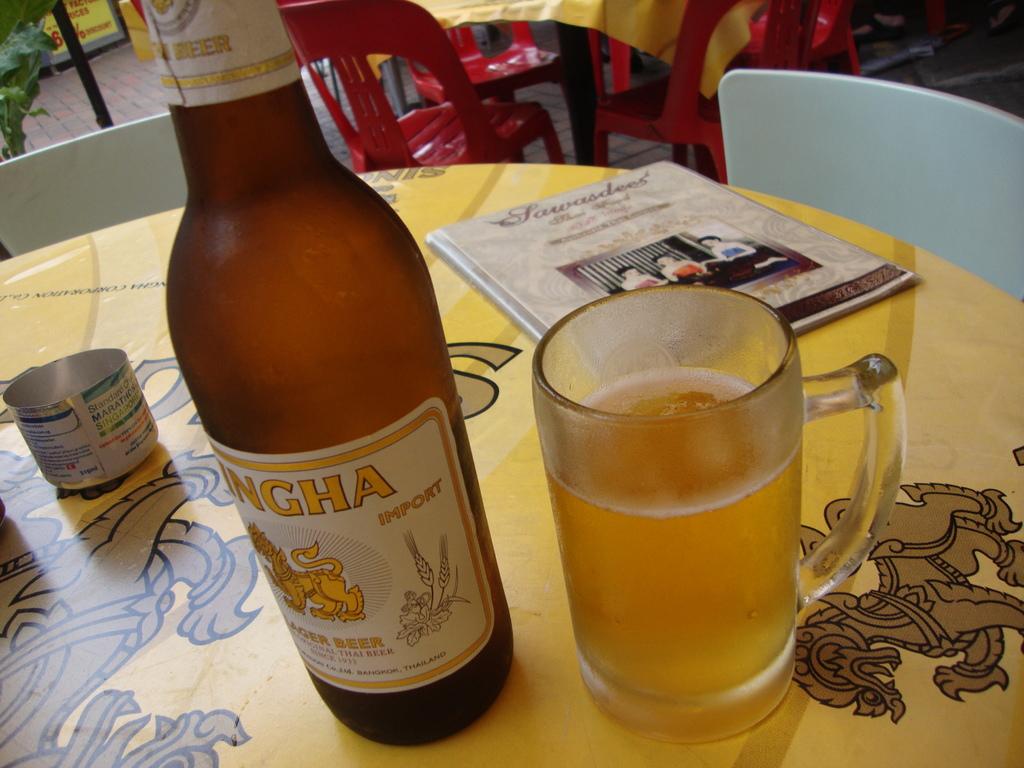From what country is the beer imported?
Ensure brevity in your answer.  Thailand. Where is this beer from?
Your answer should be compact. Thailand. 